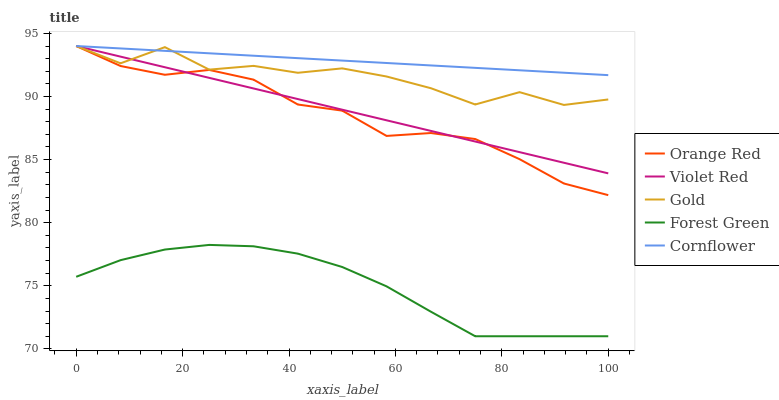Does Forest Green have the minimum area under the curve?
Answer yes or no. Yes. Does Cornflower have the maximum area under the curve?
Answer yes or no. Yes. Does Violet Red have the minimum area under the curve?
Answer yes or no. No. Does Violet Red have the maximum area under the curve?
Answer yes or no. No. Is Cornflower the smoothest?
Answer yes or no. Yes. Is Gold the roughest?
Answer yes or no. Yes. Is Violet Red the smoothest?
Answer yes or no. No. Is Violet Red the roughest?
Answer yes or no. No. Does Forest Green have the lowest value?
Answer yes or no. Yes. Does Violet Red have the lowest value?
Answer yes or no. No. Does Gold have the highest value?
Answer yes or no. Yes. Is Forest Green less than Cornflower?
Answer yes or no. Yes. Is Cornflower greater than Forest Green?
Answer yes or no. Yes. Does Violet Red intersect Cornflower?
Answer yes or no. Yes. Is Violet Red less than Cornflower?
Answer yes or no. No. Is Violet Red greater than Cornflower?
Answer yes or no. No. Does Forest Green intersect Cornflower?
Answer yes or no. No. 